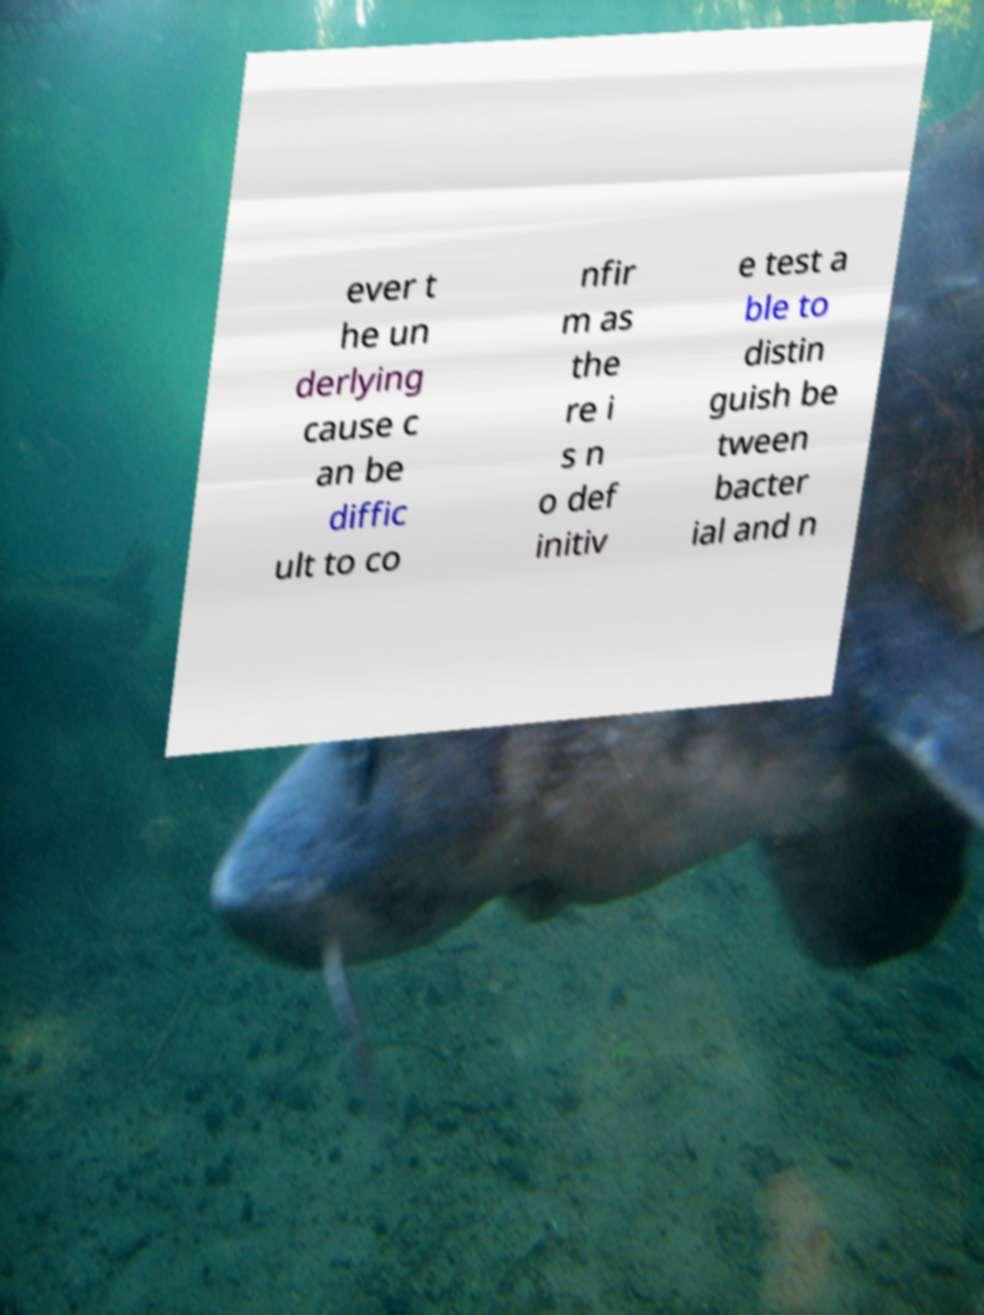Please read and relay the text visible in this image. What does it say? ever t he un derlying cause c an be diffic ult to co nfir m as the re i s n o def initiv e test a ble to distin guish be tween bacter ial and n 